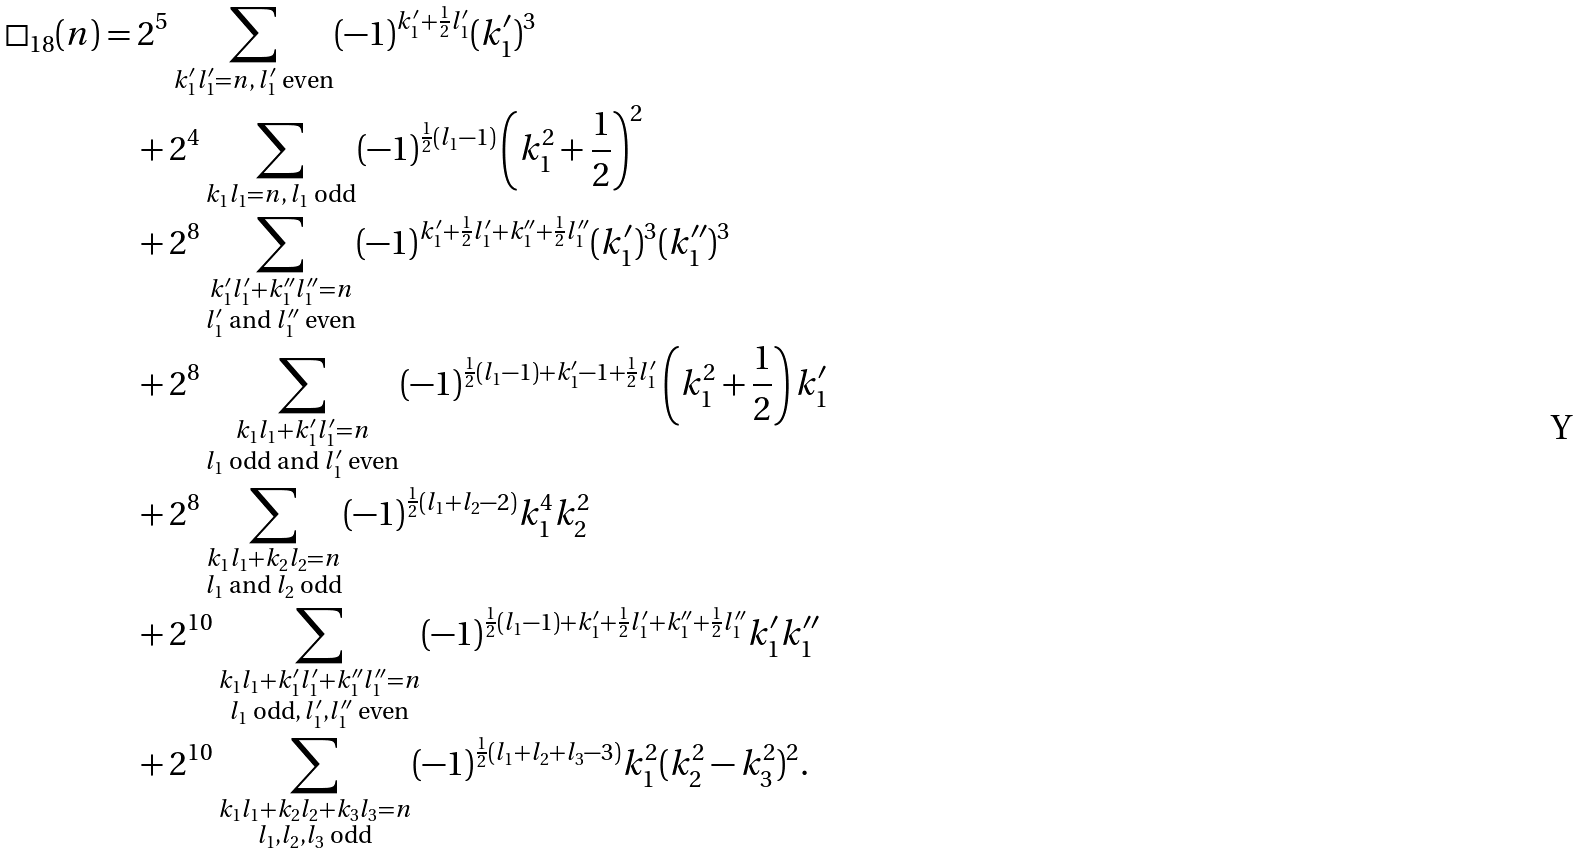<formula> <loc_0><loc_0><loc_500><loc_500>\square _ { 1 8 } ( n ) & = 2 ^ { 5 } \sum _ { k _ { 1 } ^ { \prime } l _ { 1 } ^ { \prime } = n , \, l _ { 1 } ^ { \prime } \text { even} } ( - 1 ) ^ { k _ { 1 } ^ { \prime } + \frac { 1 } { 2 } l _ { 1 } ^ { \prime } } ( k _ { 1 } ^ { \prime } ) ^ { 3 } \\ & \quad + 2 ^ { 4 } \sum _ { k _ { 1 } l _ { 1 } = n , \, l _ { 1 } \text { odd} } ( - 1 ) ^ { \frac { 1 } { 2 } ( l _ { 1 } - 1 ) } \left ( k _ { 1 } ^ { 2 } + \frac { 1 } { 2 } \right ) ^ { 2 } \\ & \quad + 2 ^ { 8 } \sum _ { \substack { k _ { 1 } ^ { \prime } l _ { 1 } ^ { \prime } + k _ { 1 } ^ { \prime \prime } l _ { 1 } ^ { \prime \prime } = n \\ l _ { 1 } ^ { \prime } \text { and } l _ { 1 } ^ { \prime \prime } \text { even} } } ( - 1 ) ^ { k _ { 1 } ^ { \prime } + \frac { 1 } { 2 } l _ { 1 } ^ { \prime } + k _ { 1 } ^ { \prime \prime } + \frac { 1 } { 2 } l _ { 1 } ^ { \prime \prime } } ( k _ { 1 } ^ { \prime } ) ^ { 3 } ( k _ { 1 } ^ { \prime \prime } ) ^ { 3 } \\ & \quad + 2 ^ { 8 } \sum _ { \substack { k _ { 1 } l _ { 1 } + k _ { 1 } ^ { \prime } l _ { 1 } ^ { \prime } = n \\ l _ { 1 } \text { odd and } l _ { 1 } ^ { \prime } \text { even} } } ( - 1 ) ^ { \frac { 1 } { 2 } ( l _ { 1 } - 1 ) + k _ { 1 } ^ { \prime } - 1 + \frac { 1 } { 2 } l _ { 1 } ^ { \prime } } \left ( k _ { 1 } ^ { 2 } + \frac { 1 } { 2 } \right ) k _ { 1 } ^ { \prime } \\ & \quad + 2 ^ { 8 } \sum _ { \substack { k _ { 1 } l _ { 1 } + k _ { 2 } l _ { 2 } = n \\ l _ { 1 } \text { and } l _ { 2 } \text { odd} } } ( - 1 ) ^ { \frac { 1 } { 2 } ( l _ { 1 } + l _ { 2 } - 2 ) } k _ { 1 } ^ { 4 } k _ { 2 } ^ { 2 } \\ & \quad + 2 ^ { 1 0 } \sum _ { \substack { k _ { 1 } l _ { 1 } + k _ { 1 } ^ { \prime } l _ { 1 } ^ { \prime } + k _ { 1 } ^ { \prime \prime } l _ { 1 } ^ { \prime \prime } = n \\ l _ { 1 } \text { odd} , \, l _ { 1 } ^ { \prime } , l _ { 1 } ^ { \prime \prime } \text { even} } } ( - 1 ) ^ { \frac { 1 } { 2 } ( l _ { 1 } - 1 ) + k _ { 1 } ^ { \prime } + \frac { 1 } { 2 } l _ { 1 } ^ { \prime } + k _ { 1 } ^ { \prime \prime } + \frac { 1 } { 2 } l _ { 1 } ^ { \prime \prime } } k _ { 1 } ^ { \prime } k _ { 1 } ^ { \prime \prime } \\ & \quad + 2 ^ { 1 0 } \sum _ { \substack { k _ { 1 } l _ { 1 } + k _ { 2 } l _ { 2 } + k _ { 3 } l _ { 3 } = n \\ l _ { 1 } , l _ { 2 } , l _ { 3 } \text { odd} } } ( - 1 ) ^ { \frac { 1 } { 2 } ( l _ { 1 } + l _ { 2 } + l _ { 3 } - 3 ) } k _ { 1 } ^ { 2 } ( k _ { 2 } ^ { 2 } - k _ { 3 } ^ { 2 } ) ^ { 2 } .</formula> 